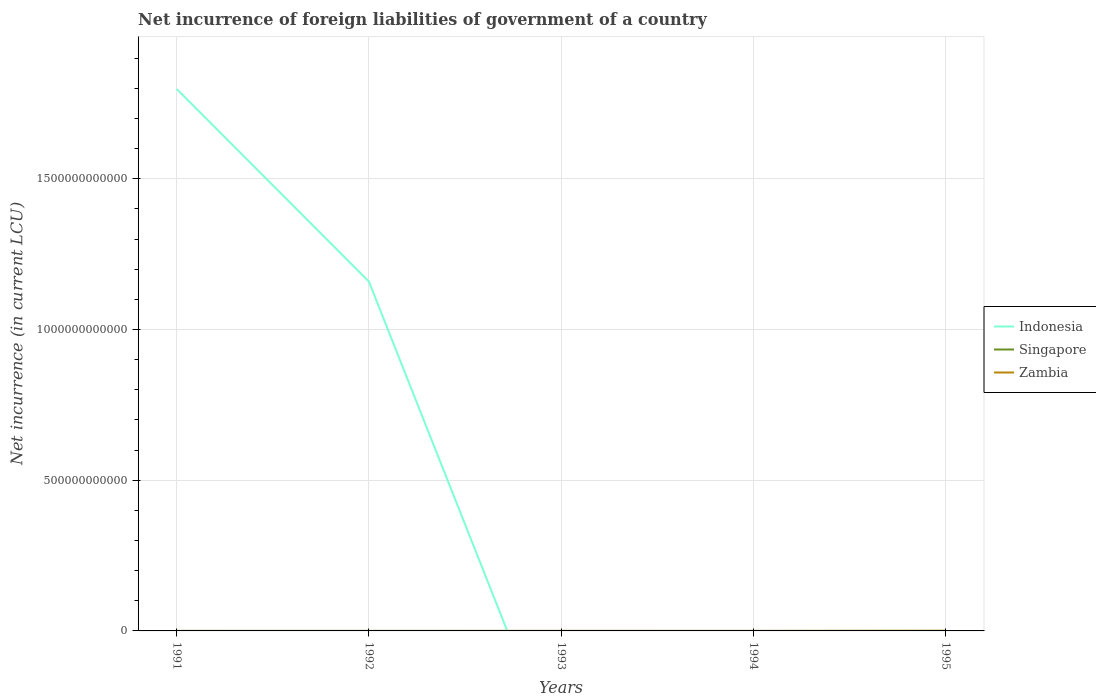How many different coloured lines are there?
Offer a terse response. 2. Across all years, what is the maximum net incurrence of foreign liabilities in Zambia?
Offer a terse response. 9.39e+04. What is the total net incurrence of foreign liabilities in Zambia in the graph?
Provide a short and direct response. -4.40e+08. What is the difference between the highest and the second highest net incurrence of foreign liabilities in Indonesia?
Your response must be concise. 1.80e+12. What is the difference between the highest and the lowest net incurrence of foreign liabilities in Singapore?
Keep it short and to the point. 0. Is the net incurrence of foreign liabilities in Zambia strictly greater than the net incurrence of foreign liabilities in Indonesia over the years?
Offer a very short reply. No. How many years are there in the graph?
Your answer should be very brief. 5. What is the difference between two consecutive major ticks on the Y-axis?
Provide a succinct answer. 5.00e+11. Does the graph contain grids?
Provide a short and direct response. Yes. How are the legend labels stacked?
Give a very brief answer. Vertical. What is the title of the graph?
Give a very brief answer. Net incurrence of foreign liabilities of government of a country. Does "Greenland" appear as one of the legend labels in the graph?
Provide a short and direct response. No. What is the label or title of the Y-axis?
Your answer should be very brief. Net incurrence (in current LCU). What is the Net incurrence (in current LCU) in Indonesia in 1991?
Provide a short and direct response. 1.80e+12. What is the Net incurrence (in current LCU) of Singapore in 1991?
Ensure brevity in your answer.  0. What is the Net incurrence (in current LCU) in Zambia in 1991?
Keep it short and to the point. 4.80e+07. What is the Net incurrence (in current LCU) in Indonesia in 1992?
Provide a succinct answer. 1.16e+12. What is the Net incurrence (in current LCU) of Zambia in 1992?
Your answer should be compact. 9.39e+04. What is the Net incurrence (in current LCU) in Singapore in 1993?
Your response must be concise. 0. What is the Net incurrence (in current LCU) of Zambia in 1993?
Keep it short and to the point. 7.76e+07. What is the Net incurrence (in current LCU) in Zambia in 1994?
Ensure brevity in your answer.  7.39e+07. What is the Net incurrence (in current LCU) of Zambia in 1995?
Your answer should be compact. 4.88e+08. Across all years, what is the maximum Net incurrence (in current LCU) in Indonesia?
Give a very brief answer. 1.80e+12. Across all years, what is the maximum Net incurrence (in current LCU) in Zambia?
Offer a terse response. 4.88e+08. Across all years, what is the minimum Net incurrence (in current LCU) of Zambia?
Your answer should be compact. 9.39e+04. What is the total Net incurrence (in current LCU) of Indonesia in the graph?
Your answer should be compact. 2.96e+12. What is the total Net incurrence (in current LCU) of Singapore in the graph?
Make the answer very short. 0. What is the total Net incurrence (in current LCU) of Zambia in the graph?
Your answer should be compact. 6.88e+08. What is the difference between the Net incurrence (in current LCU) of Indonesia in 1991 and that in 1992?
Offer a terse response. 6.39e+11. What is the difference between the Net incurrence (in current LCU) of Zambia in 1991 and that in 1992?
Your response must be concise. 4.79e+07. What is the difference between the Net incurrence (in current LCU) in Zambia in 1991 and that in 1993?
Provide a succinct answer. -2.96e+07. What is the difference between the Net incurrence (in current LCU) in Zambia in 1991 and that in 1994?
Keep it short and to the point. -2.59e+07. What is the difference between the Net incurrence (in current LCU) of Zambia in 1991 and that in 1995?
Give a very brief answer. -4.40e+08. What is the difference between the Net incurrence (in current LCU) of Zambia in 1992 and that in 1993?
Provide a short and direct response. -7.75e+07. What is the difference between the Net incurrence (in current LCU) in Zambia in 1992 and that in 1994?
Provide a succinct answer. -7.38e+07. What is the difference between the Net incurrence (in current LCU) of Zambia in 1992 and that in 1995?
Ensure brevity in your answer.  -4.88e+08. What is the difference between the Net incurrence (in current LCU) in Zambia in 1993 and that in 1994?
Ensure brevity in your answer.  3.68e+06. What is the difference between the Net incurrence (in current LCU) in Zambia in 1993 and that in 1995?
Your response must be concise. -4.11e+08. What is the difference between the Net incurrence (in current LCU) in Zambia in 1994 and that in 1995?
Your answer should be very brief. -4.14e+08. What is the difference between the Net incurrence (in current LCU) of Indonesia in 1991 and the Net incurrence (in current LCU) of Zambia in 1992?
Offer a very short reply. 1.80e+12. What is the difference between the Net incurrence (in current LCU) of Indonesia in 1991 and the Net incurrence (in current LCU) of Zambia in 1993?
Offer a terse response. 1.80e+12. What is the difference between the Net incurrence (in current LCU) in Indonesia in 1991 and the Net incurrence (in current LCU) in Zambia in 1994?
Your answer should be very brief. 1.80e+12. What is the difference between the Net incurrence (in current LCU) of Indonesia in 1991 and the Net incurrence (in current LCU) of Zambia in 1995?
Ensure brevity in your answer.  1.80e+12. What is the difference between the Net incurrence (in current LCU) of Indonesia in 1992 and the Net incurrence (in current LCU) of Zambia in 1993?
Provide a short and direct response. 1.16e+12. What is the difference between the Net incurrence (in current LCU) of Indonesia in 1992 and the Net incurrence (in current LCU) of Zambia in 1994?
Ensure brevity in your answer.  1.16e+12. What is the difference between the Net incurrence (in current LCU) in Indonesia in 1992 and the Net incurrence (in current LCU) in Zambia in 1995?
Your answer should be compact. 1.16e+12. What is the average Net incurrence (in current LCU) of Indonesia per year?
Offer a terse response. 5.91e+11. What is the average Net incurrence (in current LCU) in Singapore per year?
Your response must be concise. 0. What is the average Net incurrence (in current LCU) of Zambia per year?
Make the answer very short. 1.38e+08. In the year 1991, what is the difference between the Net incurrence (in current LCU) in Indonesia and Net incurrence (in current LCU) in Zambia?
Your answer should be compact. 1.80e+12. In the year 1992, what is the difference between the Net incurrence (in current LCU) of Indonesia and Net incurrence (in current LCU) of Zambia?
Ensure brevity in your answer.  1.16e+12. What is the ratio of the Net incurrence (in current LCU) of Indonesia in 1991 to that in 1992?
Offer a very short reply. 1.55. What is the ratio of the Net incurrence (in current LCU) of Zambia in 1991 to that in 1992?
Ensure brevity in your answer.  511.33. What is the ratio of the Net incurrence (in current LCU) of Zambia in 1991 to that in 1993?
Provide a short and direct response. 0.62. What is the ratio of the Net incurrence (in current LCU) of Zambia in 1991 to that in 1994?
Your response must be concise. 0.65. What is the ratio of the Net incurrence (in current LCU) of Zambia in 1991 to that in 1995?
Ensure brevity in your answer.  0.1. What is the ratio of the Net incurrence (in current LCU) in Zambia in 1992 to that in 1993?
Offer a terse response. 0. What is the ratio of the Net incurrence (in current LCU) in Zambia in 1992 to that in 1994?
Offer a terse response. 0. What is the ratio of the Net incurrence (in current LCU) in Zambia in 1992 to that in 1995?
Your answer should be compact. 0. What is the ratio of the Net incurrence (in current LCU) in Zambia in 1993 to that in 1994?
Offer a terse response. 1.05. What is the ratio of the Net incurrence (in current LCU) in Zambia in 1993 to that in 1995?
Make the answer very short. 0.16. What is the ratio of the Net incurrence (in current LCU) of Zambia in 1994 to that in 1995?
Provide a short and direct response. 0.15. What is the difference between the highest and the second highest Net incurrence (in current LCU) of Zambia?
Your answer should be very brief. 4.11e+08. What is the difference between the highest and the lowest Net incurrence (in current LCU) of Indonesia?
Provide a short and direct response. 1.80e+12. What is the difference between the highest and the lowest Net incurrence (in current LCU) of Zambia?
Provide a short and direct response. 4.88e+08. 